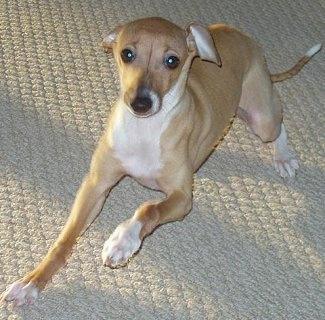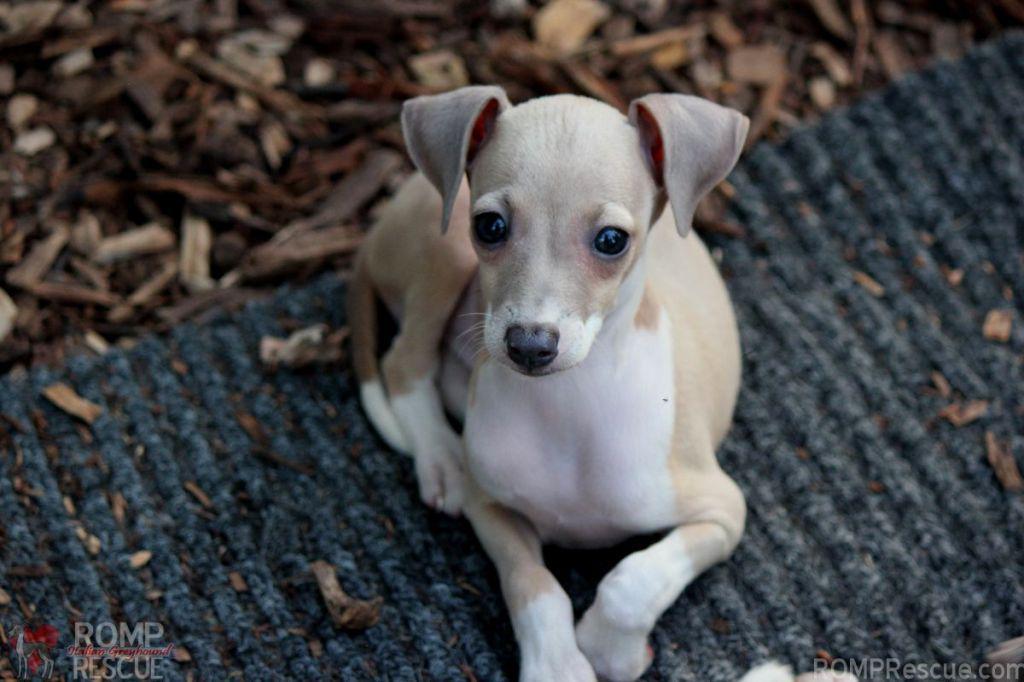The first image is the image on the left, the second image is the image on the right. Assess this claim about the two images: "A dog in one image is cradling a stuffed animal toy while lying on a furry dark gray throw.". Correct or not? Answer yes or no. No. The first image is the image on the left, the second image is the image on the right. Evaluate the accuracy of this statement regarding the images: "An image shows a hound hugging a stuffed animal.". Is it true? Answer yes or no. No. 